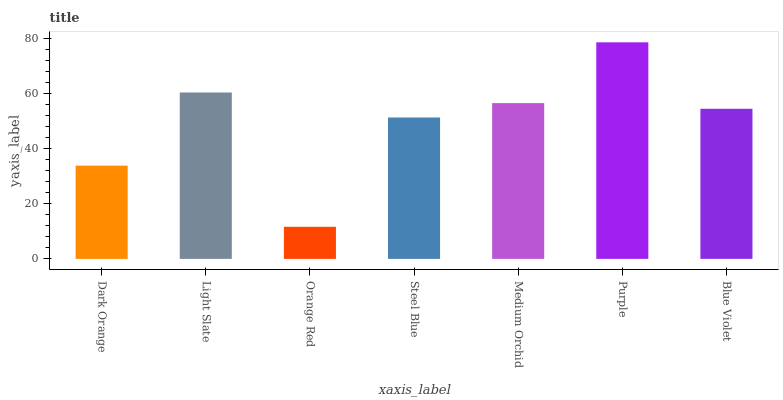Is Orange Red the minimum?
Answer yes or no. Yes. Is Purple the maximum?
Answer yes or no. Yes. Is Light Slate the minimum?
Answer yes or no. No. Is Light Slate the maximum?
Answer yes or no. No. Is Light Slate greater than Dark Orange?
Answer yes or no. Yes. Is Dark Orange less than Light Slate?
Answer yes or no. Yes. Is Dark Orange greater than Light Slate?
Answer yes or no. No. Is Light Slate less than Dark Orange?
Answer yes or no. No. Is Blue Violet the high median?
Answer yes or no. Yes. Is Blue Violet the low median?
Answer yes or no. Yes. Is Orange Red the high median?
Answer yes or no. No. Is Medium Orchid the low median?
Answer yes or no. No. 